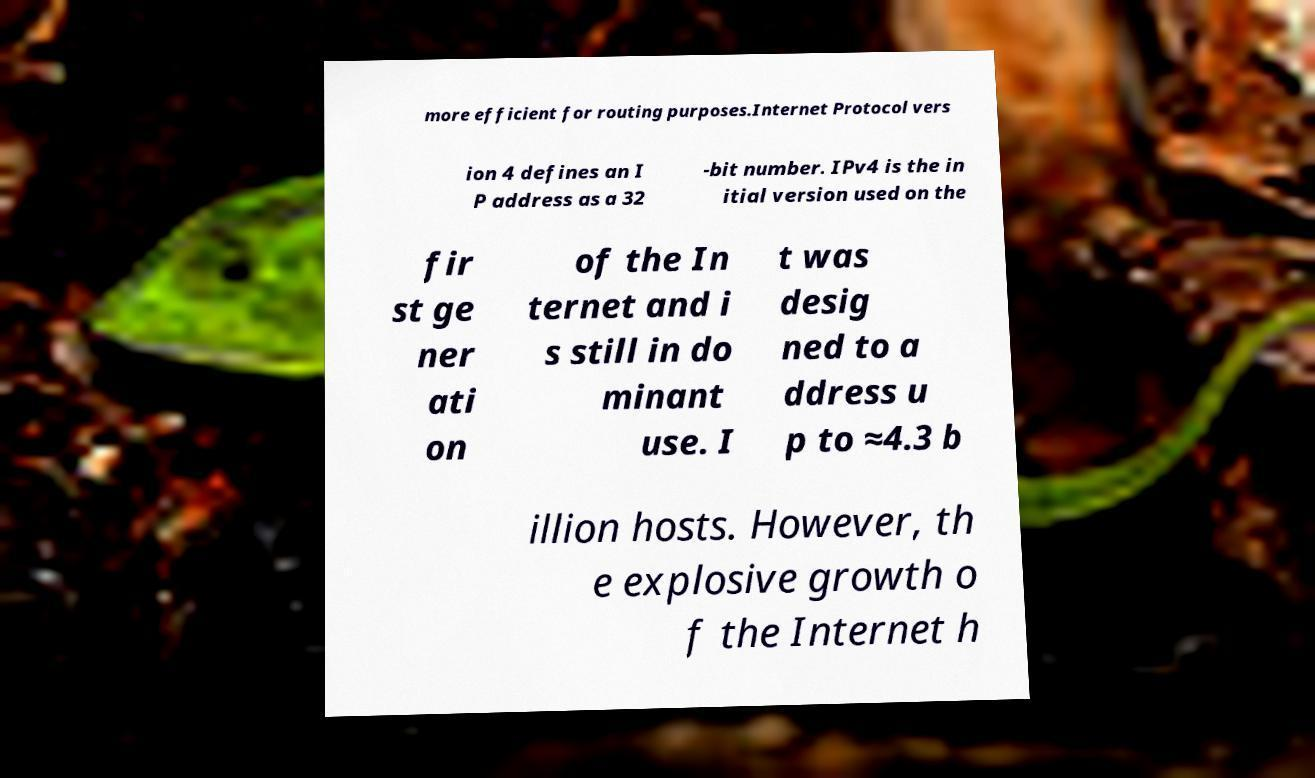Can you read and provide the text displayed in the image?This photo seems to have some interesting text. Can you extract and type it out for me? more efficient for routing purposes.Internet Protocol vers ion 4 defines an I P address as a 32 -bit number. IPv4 is the in itial version used on the fir st ge ner ati on of the In ternet and i s still in do minant use. I t was desig ned to a ddress u p to ≈4.3 b illion hosts. However, th e explosive growth o f the Internet h 